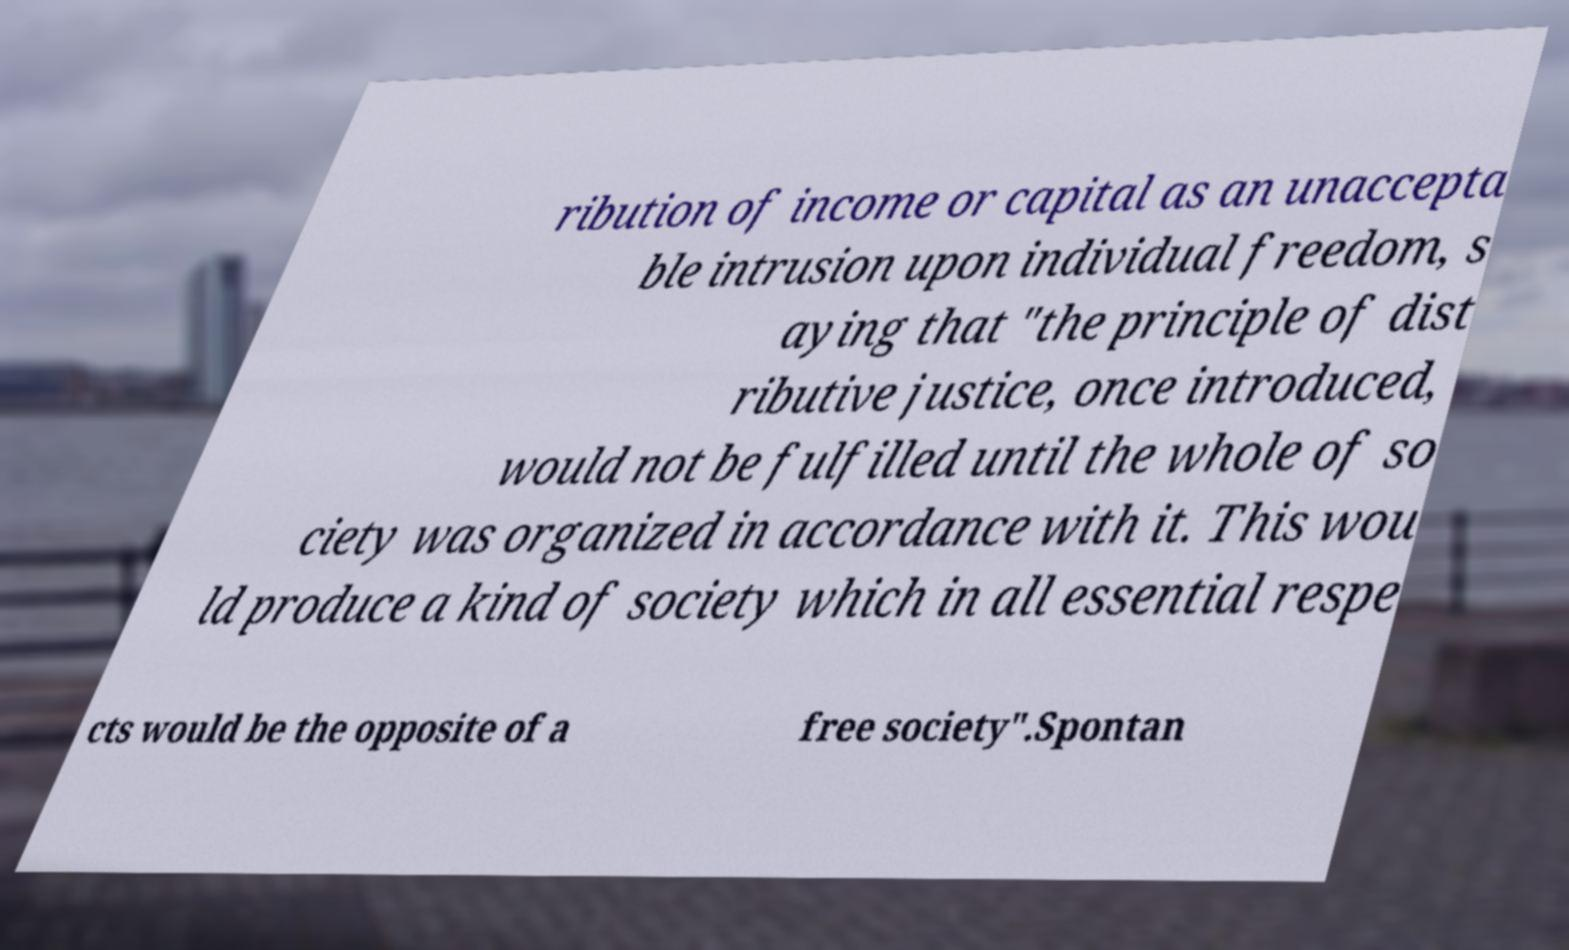Please read and relay the text visible in this image. What does it say? ribution of income or capital as an unaccepta ble intrusion upon individual freedom, s aying that "the principle of dist ributive justice, once introduced, would not be fulfilled until the whole of so ciety was organized in accordance with it. This wou ld produce a kind of society which in all essential respe cts would be the opposite of a free society".Spontan 